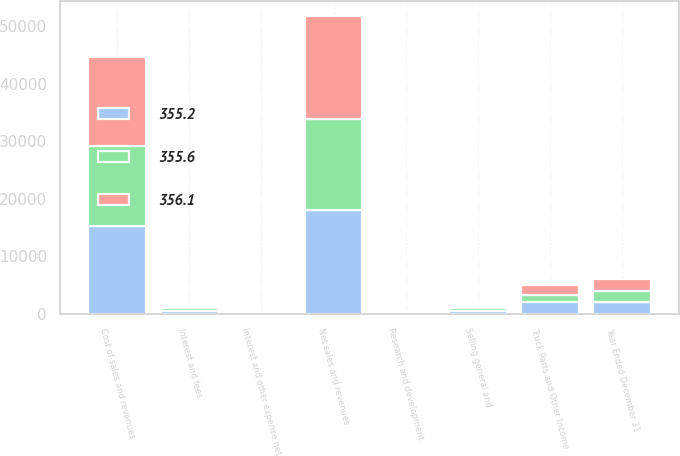<chart> <loc_0><loc_0><loc_500><loc_500><stacked_bar_chart><ecel><fcel>Year Ended December 31<fcel>Net sales and revenues<fcel>Cost of sales and revenues<fcel>Research and development<fcel>Selling general and<fcel>Interest and other expense net<fcel>Truck Parts and Other Income<fcel>Interest and fees<nl><fcel>355.2<fcel>2015<fcel>17942.8<fcel>15292.1<fcel>239.8<fcel>445.9<fcel>12.3<fcel>1952.7<fcel>443.8<nl><fcel>356.1<fcel>2014<fcel>17792.8<fcel>15481.6<fcel>215.6<fcel>465.2<fcel>5.5<fcel>1624.9<fcel>462.6<nl><fcel>355.6<fcel>2013<fcel>15948.9<fcel>13900.7<fcel>251.4<fcel>465.3<fcel>5.3<fcel>1326.2<fcel>462.8<nl></chart> 